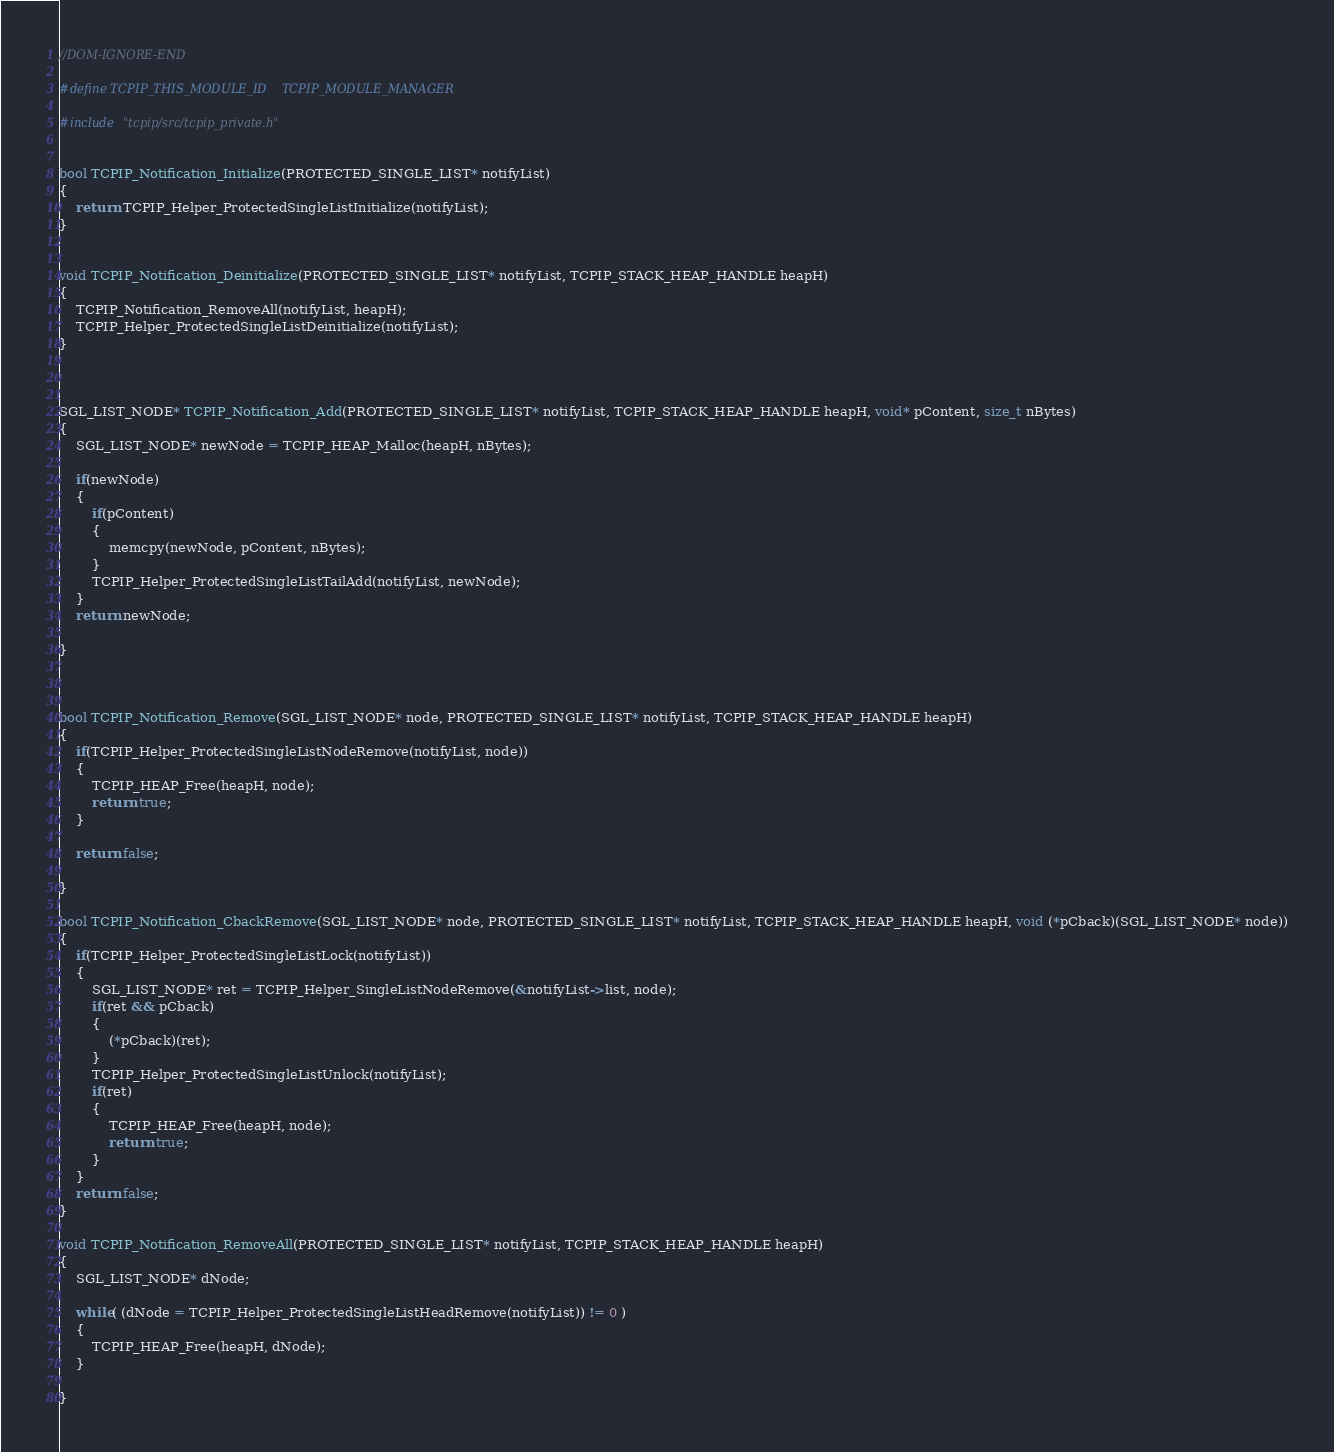Convert code to text. <code><loc_0><loc_0><loc_500><loc_500><_C_>

//DOM-IGNORE-END

#define TCPIP_THIS_MODULE_ID    TCPIP_MODULE_MANAGER

#include "tcpip/src/tcpip_private.h"


bool TCPIP_Notification_Initialize(PROTECTED_SINGLE_LIST* notifyList)
{
    return TCPIP_Helper_ProtectedSingleListInitialize(notifyList);
}


void TCPIP_Notification_Deinitialize(PROTECTED_SINGLE_LIST* notifyList, TCPIP_STACK_HEAP_HANDLE heapH)
{
    TCPIP_Notification_RemoveAll(notifyList, heapH);
    TCPIP_Helper_ProtectedSingleListDeinitialize(notifyList);
}



SGL_LIST_NODE* TCPIP_Notification_Add(PROTECTED_SINGLE_LIST* notifyList, TCPIP_STACK_HEAP_HANDLE heapH, void* pContent, size_t nBytes)
{
    SGL_LIST_NODE* newNode = TCPIP_HEAP_Malloc(heapH, nBytes);

    if(newNode)
    {
        if(pContent)
        {
            memcpy(newNode, pContent, nBytes);
        }
        TCPIP_Helper_ProtectedSingleListTailAdd(notifyList, newNode);
    }
    return newNode;

}



bool TCPIP_Notification_Remove(SGL_LIST_NODE* node, PROTECTED_SINGLE_LIST* notifyList, TCPIP_STACK_HEAP_HANDLE heapH)
{
    if(TCPIP_Helper_ProtectedSingleListNodeRemove(notifyList, node))
    {
        TCPIP_HEAP_Free(heapH, node);
        return true;
    }

    return false;

}

bool TCPIP_Notification_CbackRemove(SGL_LIST_NODE* node, PROTECTED_SINGLE_LIST* notifyList, TCPIP_STACK_HEAP_HANDLE heapH, void (*pCback)(SGL_LIST_NODE* node))
{
    if(TCPIP_Helper_ProtectedSingleListLock(notifyList))
    {
        SGL_LIST_NODE* ret = TCPIP_Helper_SingleListNodeRemove(&notifyList->list, node);
        if(ret && pCback)
        {
            (*pCback)(ret);
        }
        TCPIP_Helper_ProtectedSingleListUnlock(notifyList);
        if(ret)
        {
            TCPIP_HEAP_Free(heapH, node);
            return true;
        }
    }
    return false;
}

void TCPIP_Notification_RemoveAll(PROTECTED_SINGLE_LIST* notifyList, TCPIP_STACK_HEAP_HANDLE heapH)
{
    SGL_LIST_NODE* dNode;

    while( (dNode = TCPIP_Helper_ProtectedSingleListHeadRemove(notifyList)) != 0 )
    {
        TCPIP_HEAP_Free(heapH, dNode);
    }

}




</code> 